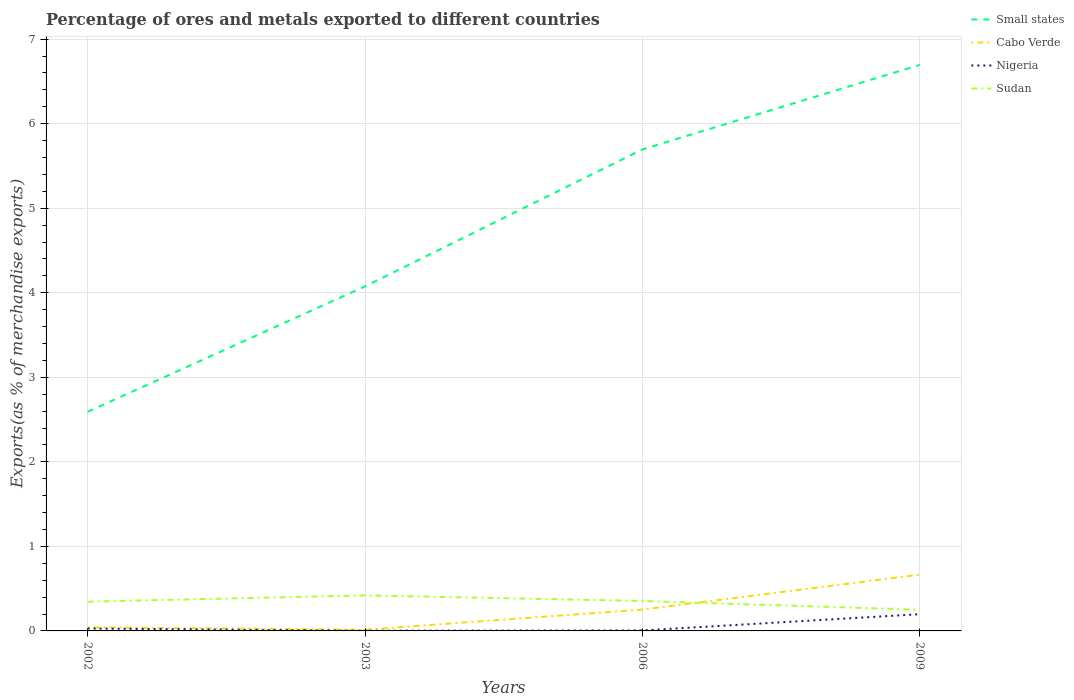Across all years, what is the maximum percentage of exports to different countries in Cabo Verde?
Your answer should be compact. 0.01. What is the total percentage of exports to different countries in Small states in the graph?
Ensure brevity in your answer.  -1.48. What is the difference between the highest and the second highest percentage of exports to different countries in Cabo Verde?
Give a very brief answer. 0.65. Is the percentage of exports to different countries in Cabo Verde strictly greater than the percentage of exports to different countries in Small states over the years?
Your response must be concise. Yes. How many lines are there?
Your answer should be compact. 4. How many years are there in the graph?
Ensure brevity in your answer.  4. Does the graph contain any zero values?
Make the answer very short. No. Does the graph contain grids?
Your answer should be very brief. Yes. How many legend labels are there?
Make the answer very short. 4. How are the legend labels stacked?
Your answer should be very brief. Vertical. What is the title of the graph?
Make the answer very short. Percentage of ores and metals exported to different countries. What is the label or title of the X-axis?
Your response must be concise. Years. What is the label or title of the Y-axis?
Your response must be concise. Exports(as % of merchandise exports). What is the Exports(as % of merchandise exports) of Small states in 2002?
Offer a terse response. 2.59. What is the Exports(as % of merchandise exports) of Cabo Verde in 2002?
Make the answer very short. 0.04. What is the Exports(as % of merchandise exports) in Nigeria in 2002?
Your response must be concise. 0.03. What is the Exports(as % of merchandise exports) of Sudan in 2002?
Give a very brief answer. 0.35. What is the Exports(as % of merchandise exports) of Small states in 2003?
Your answer should be compact. 4.08. What is the Exports(as % of merchandise exports) in Cabo Verde in 2003?
Keep it short and to the point. 0.01. What is the Exports(as % of merchandise exports) in Nigeria in 2003?
Offer a terse response. 0. What is the Exports(as % of merchandise exports) of Sudan in 2003?
Give a very brief answer. 0.42. What is the Exports(as % of merchandise exports) of Small states in 2006?
Offer a very short reply. 5.7. What is the Exports(as % of merchandise exports) of Cabo Verde in 2006?
Offer a terse response. 0.25. What is the Exports(as % of merchandise exports) of Nigeria in 2006?
Your answer should be compact. 0.01. What is the Exports(as % of merchandise exports) of Sudan in 2006?
Your response must be concise. 0.35. What is the Exports(as % of merchandise exports) in Small states in 2009?
Your answer should be very brief. 6.7. What is the Exports(as % of merchandise exports) in Cabo Verde in 2009?
Keep it short and to the point. 0.67. What is the Exports(as % of merchandise exports) in Nigeria in 2009?
Provide a succinct answer. 0.2. What is the Exports(as % of merchandise exports) of Sudan in 2009?
Ensure brevity in your answer.  0.25. Across all years, what is the maximum Exports(as % of merchandise exports) of Small states?
Your answer should be compact. 6.7. Across all years, what is the maximum Exports(as % of merchandise exports) in Cabo Verde?
Ensure brevity in your answer.  0.67. Across all years, what is the maximum Exports(as % of merchandise exports) of Nigeria?
Give a very brief answer. 0.2. Across all years, what is the maximum Exports(as % of merchandise exports) of Sudan?
Provide a succinct answer. 0.42. Across all years, what is the minimum Exports(as % of merchandise exports) in Small states?
Your response must be concise. 2.59. Across all years, what is the minimum Exports(as % of merchandise exports) of Cabo Verde?
Your answer should be compact. 0.01. Across all years, what is the minimum Exports(as % of merchandise exports) in Nigeria?
Offer a terse response. 0. Across all years, what is the minimum Exports(as % of merchandise exports) of Sudan?
Make the answer very short. 0.25. What is the total Exports(as % of merchandise exports) in Small states in the graph?
Provide a short and direct response. 19.06. What is the total Exports(as % of merchandise exports) of Cabo Verde in the graph?
Your answer should be very brief. 0.97. What is the total Exports(as % of merchandise exports) of Nigeria in the graph?
Provide a succinct answer. 0.24. What is the total Exports(as % of merchandise exports) in Sudan in the graph?
Provide a succinct answer. 1.37. What is the difference between the Exports(as % of merchandise exports) of Small states in 2002 and that in 2003?
Keep it short and to the point. -1.48. What is the difference between the Exports(as % of merchandise exports) of Cabo Verde in 2002 and that in 2003?
Make the answer very short. 0.03. What is the difference between the Exports(as % of merchandise exports) in Nigeria in 2002 and that in 2003?
Offer a terse response. 0.03. What is the difference between the Exports(as % of merchandise exports) of Sudan in 2002 and that in 2003?
Offer a terse response. -0.07. What is the difference between the Exports(as % of merchandise exports) of Small states in 2002 and that in 2006?
Give a very brief answer. -3.1. What is the difference between the Exports(as % of merchandise exports) of Cabo Verde in 2002 and that in 2006?
Keep it short and to the point. -0.21. What is the difference between the Exports(as % of merchandise exports) of Nigeria in 2002 and that in 2006?
Offer a very short reply. 0.02. What is the difference between the Exports(as % of merchandise exports) in Sudan in 2002 and that in 2006?
Your answer should be compact. -0.01. What is the difference between the Exports(as % of merchandise exports) in Small states in 2002 and that in 2009?
Your answer should be compact. -4.1. What is the difference between the Exports(as % of merchandise exports) in Cabo Verde in 2002 and that in 2009?
Offer a terse response. -0.62. What is the difference between the Exports(as % of merchandise exports) in Nigeria in 2002 and that in 2009?
Your answer should be compact. -0.17. What is the difference between the Exports(as % of merchandise exports) in Sudan in 2002 and that in 2009?
Your response must be concise. 0.1. What is the difference between the Exports(as % of merchandise exports) of Small states in 2003 and that in 2006?
Ensure brevity in your answer.  -1.62. What is the difference between the Exports(as % of merchandise exports) of Cabo Verde in 2003 and that in 2006?
Offer a very short reply. -0.24. What is the difference between the Exports(as % of merchandise exports) of Nigeria in 2003 and that in 2006?
Make the answer very short. -0. What is the difference between the Exports(as % of merchandise exports) in Sudan in 2003 and that in 2006?
Offer a terse response. 0.07. What is the difference between the Exports(as % of merchandise exports) of Small states in 2003 and that in 2009?
Offer a very short reply. -2.62. What is the difference between the Exports(as % of merchandise exports) of Cabo Verde in 2003 and that in 2009?
Provide a short and direct response. -0.65. What is the difference between the Exports(as % of merchandise exports) of Nigeria in 2003 and that in 2009?
Your answer should be compact. -0.2. What is the difference between the Exports(as % of merchandise exports) in Sudan in 2003 and that in 2009?
Your answer should be compact. 0.17. What is the difference between the Exports(as % of merchandise exports) of Small states in 2006 and that in 2009?
Offer a terse response. -1. What is the difference between the Exports(as % of merchandise exports) of Cabo Verde in 2006 and that in 2009?
Keep it short and to the point. -0.41. What is the difference between the Exports(as % of merchandise exports) in Nigeria in 2006 and that in 2009?
Provide a short and direct response. -0.19. What is the difference between the Exports(as % of merchandise exports) of Sudan in 2006 and that in 2009?
Make the answer very short. 0.1. What is the difference between the Exports(as % of merchandise exports) in Small states in 2002 and the Exports(as % of merchandise exports) in Cabo Verde in 2003?
Keep it short and to the point. 2.58. What is the difference between the Exports(as % of merchandise exports) in Small states in 2002 and the Exports(as % of merchandise exports) in Nigeria in 2003?
Keep it short and to the point. 2.59. What is the difference between the Exports(as % of merchandise exports) of Small states in 2002 and the Exports(as % of merchandise exports) of Sudan in 2003?
Make the answer very short. 2.17. What is the difference between the Exports(as % of merchandise exports) of Cabo Verde in 2002 and the Exports(as % of merchandise exports) of Nigeria in 2003?
Give a very brief answer. 0.04. What is the difference between the Exports(as % of merchandise exports) in Cabo Verde in 2002 and the Exports(as % of merchandise exports) in Sudan in 2003?
Your answer should be very brief. -0.38. What is the difference between the Exports(as % of merchandise exports) of Nigeria in 2002 and the Exports(as % of merchandise exports) of Sudan in 2003?
Your answer should be compact. -0.39. What is the difference between the Exports(as % of merchandise exports) of Small states in 2002 and the Exports(as % of merchandise exports) of Cabo Verde in 2006?
Your answer should be compact. 2.34. What is the difference between the Exports(as % of merchandise exports) in Small states in 2002 and the Exports(as % of merchandise exports) in Nigeria in 2006?
Ensure brevity in your answer.  2.59. What is the difference between the Exports(as % of merchandise exports) of Small states in 2002 and the Exports(as % of merchandise exports) of Sudan in 2006?
Your answer should be compact. 2.24. What is the difference between the Exports(as % of merchandise exports) in Cabo Verde in 2002 and the Exports(as % of merchandise exports) in Nigeria in 2006?
Make the answer very short. 0.04. What is the difference between the Exports(as % of merchandise exports) in Cabo Verde in 2002 and the Exports(as % of merchandise exports) in Sudan in 2006?
Your answer should be very brief. -0.31. What is the difference between the Exports(as % of merchandise exports) in Nigeria in 2002 and the Exports(as % of merchandise exports) in Sudan in 2006?
Your response must be concise. -0.33. What is the difference between the Exports(as % of merchandise exports) of Small states in 2002 and the Exports(as % of merchandise exports) of Cabo Verde in 2009?
Your answer should be compact. 1.93. What is the difference between the Exports(as % of merchandise exports) in Small states in 2002 and the Exports(as % of merchandise exports) in Nigeria in 2009?
Make the answer very short. 2.39. What is the difference between the Exports(as % of merchandise exports) in Small states in 2002 and the Exports(as % of merchandise exports) in Sudan in 2009?
Your answer should be compact. 2.34. What is the difference between the Exports(as % of merchandise exports) in Cabo Verde in 2002 and the Exports(as % of merchandise exports) in Nigeria in 2009?
Give a very brief answer. -0.16. What is the difference between the Exports(as % of merchandise exports) in Cabo Verde in 2002 and the Exports(as % of merchandise exports) in Sudan in 2009?
Make the answer very short. -0.21. What is the difference between the Exports(as % of merchandise exports) of Nigeria in 2002 and the Exports(as % of merchandise exports) of Sudan in 2009?
Provide a short and direct response. -0.22. What is the difference between the Exports(as % of merchandise exports) of Small states in 2003 and the Exports(as % of merchandise exports) of Cabo Verde in 2006?
Provide a short and direct response. 3.82. What is the difference between the Exports(as % of merchandise exports) of Small states in 2003 and the Exports(as % of merchandise exports) of Nigeria in 2006?
Your answer should be very brief. 4.07. What is the difference between the Exports(as % of merchandise exports) of Small states in 2003 and the Exports(as % of merchandise exports) of Sudan in 2006?
Give a very brief answer. 3.72. What is the difference between the Exports(as % of merchandise exports) in Cabo Verde in 2003 and the Exports(as % of merchandise exports) in Nigeria in 2006?
Your response must be concise. 0.01. What is the difference between the Exports(as % of merchandise exports) in Cabo Verde in 2003 and the Exports(as % of merchandise exports) in Sudan in 2006?
Provide a short and direct response. -0.34. What is the difference between the Exports(as % of merchandise exports) in Nigeria in 2003 and the Exports(as % of merchandise exports) in Sudan in 2006?
Keep it short and to the point. -0.35. What is the difference between the Exports(as % of merchandise exports) in Small states in 2003 and the Exports(as % of merchandise exports) in Cabo Verde in 2009?
Provide a succinct answer. 3.41. What is the difference between the Exports(as % of merchandise exports) in Small states in 2003 and the Exports(as % of merchandise exports) in Nigeria in 2009?
Your response must be concise. 3.88. What is the difference between the Exports(as % of merchandise exports) of Small states in 2003 and the Exports(as % of merchandise exports) of Sudan in 2009?
Offer a very short reply. 3.82. What is the difference between the Exports(as % of merchandise exports) in Cabo Verde in 2003 and the Exports(as % of merchandise exports) in Nigeria in 2009?
Make the answer very short. -0.18. What is the difference between the Exports(as % of merchandise exports) in Cabo Verde in 2003 and the Exports(as % of merchandise exports) in Sudan in 2009?
Give a very brief answer. -0.24. What is the difference between the Exports(as % of merchandise exports) of Nigeria in 2003 and the Exports(as % of merchandise exports) of Sudan in 2009?
Make the answer very short. -0.25. What is the difference between the Exports(as % of merchandise exports) of Small states in 2006 and the Exports(as % of merchandise exports) of Cabo Verde in 2009?
Your answer should be very brief. 5.03. What is the difference between the Exports(as % of merchandise exports) of Small states in 2006 and the Exports(as % of merchandise exports) of Nigeria in 2009?
Give a very brief answer. 5.5. What is the difference between the Exports(as % of merchandise exports) in Small states in 2006 and the Exports(as % of merchandise exports) in Sudan in 2009?
Give a very brief answer. 5.45. What is the difference between the Exports(as % of merchandise exports) in Cabo Verde in 2006 and the Exports(as % of merchandise exports) in Nigeria in 2009?
Offer a terse response. 0.05. What is the difference between the Exports(as % of merchandise exports) in Cabo Verde in 2006 and the Exports(as % of merchandise exports) in Sudan in 2009?
Make the answer very short. 0. What is the difference between the Exports(as % of merchandise exports) in Nigeria in 2006 and the Exports(as % of merchandise exports) in Sudan in 2009?
Keep it short and to the point. -0.24. What is the average Exports(as % of merchandise exports) of Small states per year?
Keep it short and to the point. 4.76. What is the average Exports(as % of merchandise exports) in Cabo Verde per year?
Provide a succinct answer. 0.24. What is the average Exports(as % of merchandise exports) in Nigeria per year?
Offer a terse response. 0.06. What is the average Exports(as % of merchandise exports) of Sudan per year?
Ensure brevity in your answer.  0.34. In the year 2002, what is the difference between the Exports(as % of merchandise exports) of Small states and Exports(as % of merchandise exports) of Cabo Verde?
Offer a very short reply. 2.55. In the year 2002, what is the difference between the Exports(as % of merchandise exports) in Small states and Exports(as % of merchandise exports) in Nigeria?
Offer a very short reply. 2.56. In the year 2002, what is the difference between the Exports(as % of merchandise exports) of Small states and Exports(as % of merchandise exports) of Sudan?
Offer a very short reply. 2.25. In the year 2002, what is the difference between the Exports(as % of merchandise exports) in Cabo Verde and Exports(as % of merchandise exports) in Nigeria?
Your response must be concise. 0.01. In the year 2002, what is the difference between the Exports(as % of merchandise exports) in Cabo Verde and Exports(as % of merchandise exports) in Sudan?
Give a very brief answer. -0.3. In the year 2002, what is the difference between the Exports(as % of merchandise exports) of Nigeria and Exports(as % of merchandise exports) of Sudan?
Offer a terse response. -0.32. In the year 2003, what is the difference between the Exports(as % of merchandise exports) of Small states and Exports(as % of merchandise exports) of Cabo Verde?
Keep it short and to the point. 4.06. In the year 2003, what is the difference between the Exports(as % of merchandise exports) in Small states and Exports(as % of merchandise exports) in Nigeria?
Your answer should be compact. 4.07. In the year 2003, what is the difference between the Exports(as % of merchandise exports) in Small states and Exports(as % of merchandise exports) in Sudan?
Provide a succinct answer. 3.65. In the year 2003, what is the difference between the Exports(as % of merchandise exports) in Cabo Verde and Exports(as % of merchandise exports) in Nigeria?
Provide a short and direct response. 0.01. In the year 2003, what is the difference between the Exports(as % of merchandise exports) in Cabo Verde and Exports(as % of merchandise exports) in Sudan?
Offer a very short reply. -0.41. In the year 2003, what is the difference between the Exports(as % of merchandise exports) in Nigeria and Exports(as % of merchandise exports) in Sudan?
Your response must be concise. -0.42. In the year 2006, what is the difference between the Exports(as % of merchandise exports) of Small states and Exports(as % of merchandise exports) of Cabo Verde?
Your answer should be compact. 5.44. In the year 2006, what is the difference between the Exports(as % of merchandise exports) of Small states and Exports(as % of merchandise exports) of Nigeria?
Ensure brevity in your answer.  5.69. In the year 2006, what is the difference between the Exports(as % of merchandise exports) of Small states and Exports(as % of merchandise exports) of Sudan?
Keep it short and to the point. 5.34. In the year 2006, what is the difference between the Exports(as % of merchandise exports) in Cabo Verde and Exports(as % of merchandise exports) in Nigeria?
Provide a short and direct response. 0.25. In the year 2006, what is the difference between the Exports(as % of merchandise exports) of Cabo Verde and Exports(as % of merchandise exports) of Sudan?
Your answer should be compact. -0.1. In the year 2006, what is the difference between the Exports(as % of merchandise exports) in Nigeria and Exports(as % of merchandise exports) in Sudan?
Offer a terse response. -0.35. In the year 2009, what is the difference between the Exports(as % of merchandise exports) of Small states and Exports(as % of merchandise exports) of Cabo Verde?
Offer a very short reply. 6.03. In the year 2009, what is the difference between the Exports(as % of merchandise exports) in Small states and Exports(as % of merchandise exports) in Nigeria?
Offer a terse response. 6.5. In the year 2009, what is the difference between the Exports(as % of merchandise exports) of Small states and Exports(as % of merchandise exports) of Sudan?
Keep it short and to the point. 6.45. In the year 2009, what is the difference between the Exports(as % of merchandise exports) in Cabo Verde and Exports(as % of merchandise exports) in Nigeria?
Offer a very short reply. 0.47. In the year 2009, what is the difference between the Exports(as % of merchandise exports) of Cabo Verde and Exports(as % of merchandise exports) of Sudan?
Offer a very short reply. 0.42. In the year 2009, what is the difference between the Exports(as % of merchandise exports) in Nigeria and Exports(as % of merchandise exports) in Sudan?
Ensure brevity in your answer.  -0.05. What is the ratio of the Exports(as % of merchandise exports) of Small states in 2002 to that in 2003?
Provide a short and direct response. 0.64. What is the ratio of the Exports(as % of merchandise exports) of Cabo Verde in 2002 to that in 2003?
Offer a terse response. 2.86. What is the ratio of the Exports(as % of merchandise exports) of Nigeria in 2002 to that in 2003?
Give a very brief answer. 10.03. What is the ratio of the Exports(as % of merchandise exports) of Sudan in 2002 to that in 2003?
Make the answer very short. 0.82. What is the ratio of the Exports(as % of merchandise exports) in Small states in 2002 to that in 2006?
Give a very brief answer. 0.46. What is the ratio of the Exports(as % of merchandise exports) of Cabo Verde in 2002 to that in 2006?
Your response must be concise. 0.17. What is the ratio of the Exports(as % of merchandise exports) of Nigeria in 2002 to that in 2006?
Make the answer very short. 4.96. What is the ratio of the Exports(as % of merchandise exports) in Sudan in 2002 to that in 2006?
Offer a terse response. 0.98. What is the ratio of the Exports(as % of merchandise exports) in Small states in 2002 to that in 2009?
Your answer should be very brief. 0.39. What is the ratio of the Exports(as % of merchandise exports) in Cabo Verde in 2002 to that in 2009?
Give a very brief answer. 0.06. What is the ratio of the Exports(as % of merchandise exports) in Nigeria in 2002 to that in 2009?
Make the answer very short. 0.14. What is the ratio of the Exports(as % of merchandise exports) of Sudan in 2002 to that in 2009?
Ensure brevity in your answer.  1.38. What is the ratio of the Exports(as % of merchandise exports) in Small states in 2003 to that in 2006?
Your answer should be very brief. 0.72. What is the ratio of the Exports(as % of merchandise exports) in Cabo Verde in 2003 to that in 2006?
Offer a very short reply. 0.06. What is the ratio of the Exports(as % of merchandise exports) in Nigeria in 2003 to that in 2006?
Offer a very short reply. 0.49. What is the ratio of the Exports(as % of merchandise exports) of Sudan in 2003 to that in 2006?
Your answer should be compact. 1.19. What is the ratio of the Exports(as % of merchandise exports) of Small states in 2003 to that in 2009?
Give a very brief answer. 0.61. What is the ratio of the Exports(as % of merchandise exports) of Cabo Verde in 2003 to that in 2009?
Provide a succinct answer. 0.02. What is the ratio of the Exports(as % of merchandise exports) in Nigeria in 2003 to that in 2009?
Provide a short and direct response. 0.01. What is the ratio of the Exports(as % of merchandise exports) of Sudan in 2003 to that in 2009?
Provide a succinct answer. 1.68. What is the ratio of the Exports(as % of merchandise exports) in Small states in 2006 to that in 2009?
Ensure brevity in your answer.  0.85. What is the ratio of the Exports(as % of merchandise exports) in Cabo Verde in 2006 to that in 2009?
Your answer should be compact. 0.38. What is the ratio of the Exports(as % of merchandise exports) of Nigeria in 2006 to that in 2009?
Make the answer very short. 0.03. What is the ratio of the Exports(as % of merchandise exports) in Sudan in 2006 to that in 2009?
Provide a short and direct response. 1.42. What is the difference between the highest and the second highest Exports(as % of merchandise exports) of Small states?
Make the answer very short. 1. What is the difference between the highest and the second highest Exports(as % of merchandise exports) in Cabo Verde?
Your answer should be compact. 0.41. What is the difference between the highest and the second highest Exports(as % of merchandise exports) in Nigeria?
Your response must be concise. 0.17. What is the difference between the highest and the second highest Exports(as % of merchandise exports) of Sudan?
Provide a short and direct response. 0.07. What is the difference between the highest and the lowest Exports(as % of merchandise exports) of Small states?
Ensure brevity in your answer.  4.1. What is the difference between the highest and the lowest Exports(as % of merchandise exports) of Cabo Verde?
Your answer should be very brief. 0.65. What is the difference between the highest and the lowest Exports(as % of merchandise exports) of Nigeria?
Offer a terse response. 0.2. What is the difference between the highest and the lowest Exports(as % of merchandise exports) in Sudan?
Ensure brevity in your answer.  0.17. 